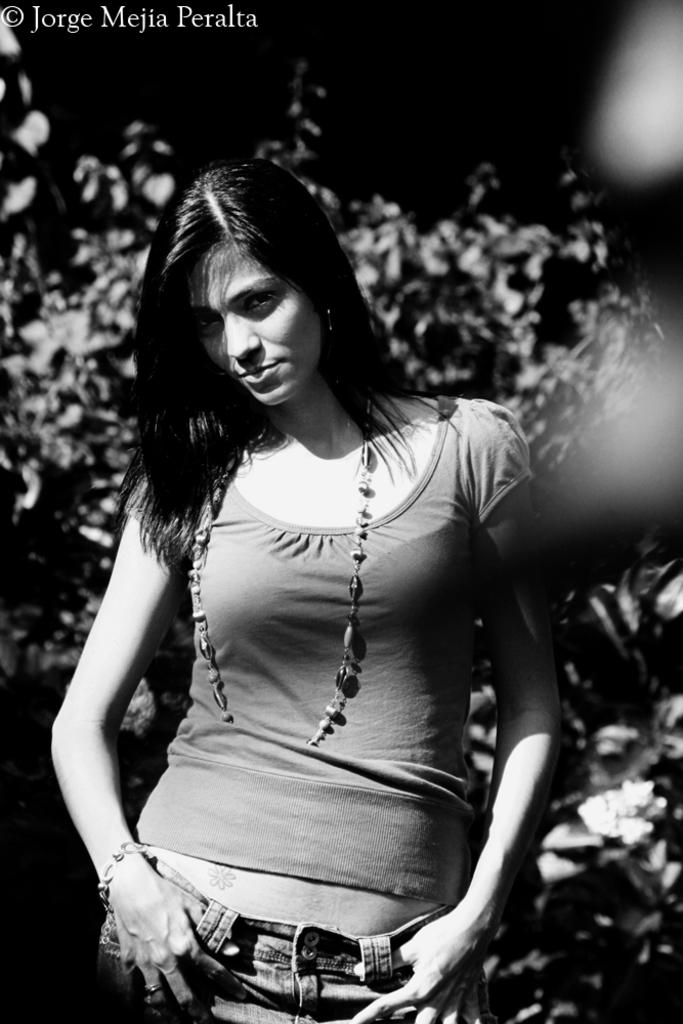What is the main subject of the image? There is a woman standing in the image. What can be observed about the background of the image? The background of the image is dark. What type of vegetation is visible in the image? There are plants visible in the image. What specific part of the plants can be seen in the image? Leaves are present in the image. What type of apparel is the iron wearing in the image? There is no iron present in the image, and therefore no apparel can be associated with it. 